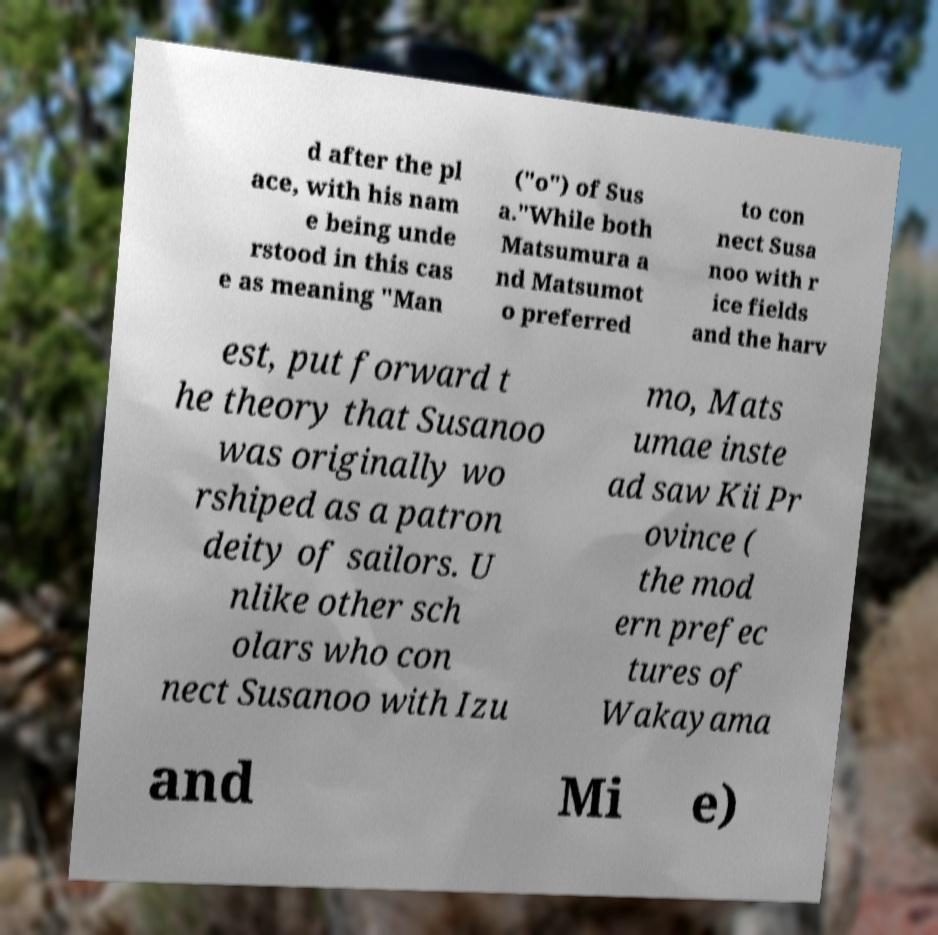Please read and relay the text visible in this image. What does it say? d after the pl ace, with his nam e being unde rstood in this cas e as meaning "Man ("o") of Sus a."While both Matsumura a nd Matsumot o preferred to con nect Susa noo with r ice fields and the harv est, put forward t he theory that Susanoo was originally wo rshiped as a patron deity of sailors. U nlike other sch olars who con nect Susanoo with Izu mo, Mats umae inste ad saw Kii Pr ovince ( the mod ern prefec tures of Wakayama and Mi e) 